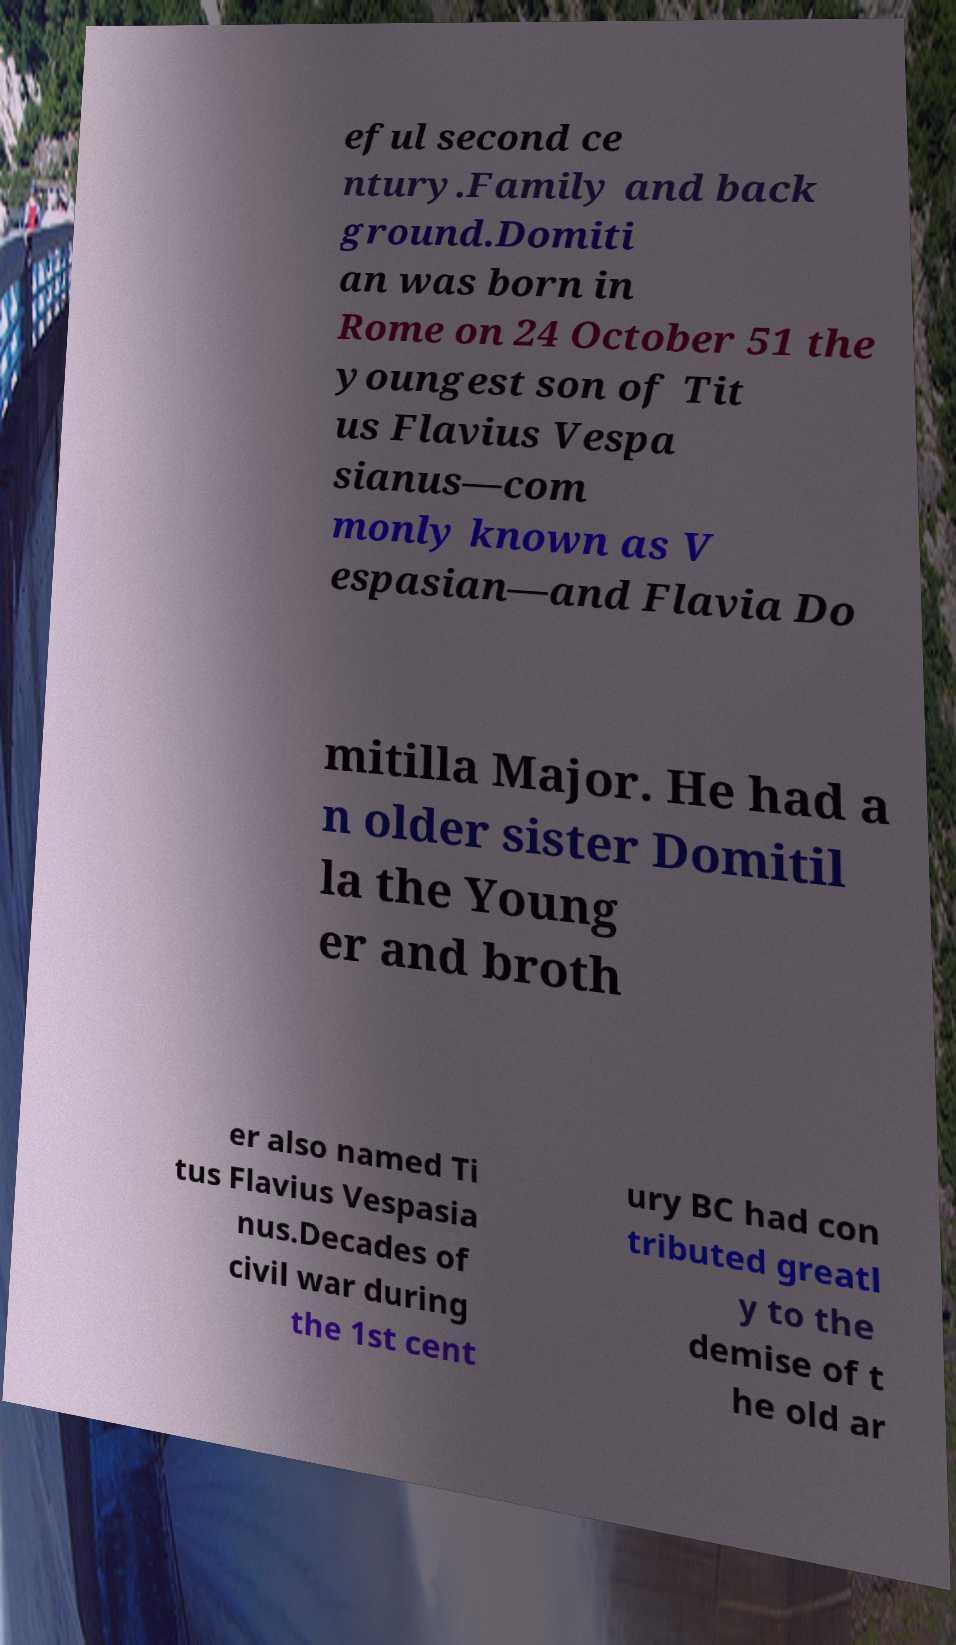For documentation purposes, I need the text within this image transcribed. Could you provide that? eful second ce ntury.Family and back ground.Domiti an was born in Rome on 24 October 51 the youngest son of Tit us Flavius Vespa sianus—com monly known as V espasian—and Flavia Do mitilla Major. He had a n older sister Domitil la the Young er and broth er also named Ti tus Flavius Vespasia nus.Decades of civil war during the 1st cent ury BC had con tributed greatl y to the demise of t he old ar 